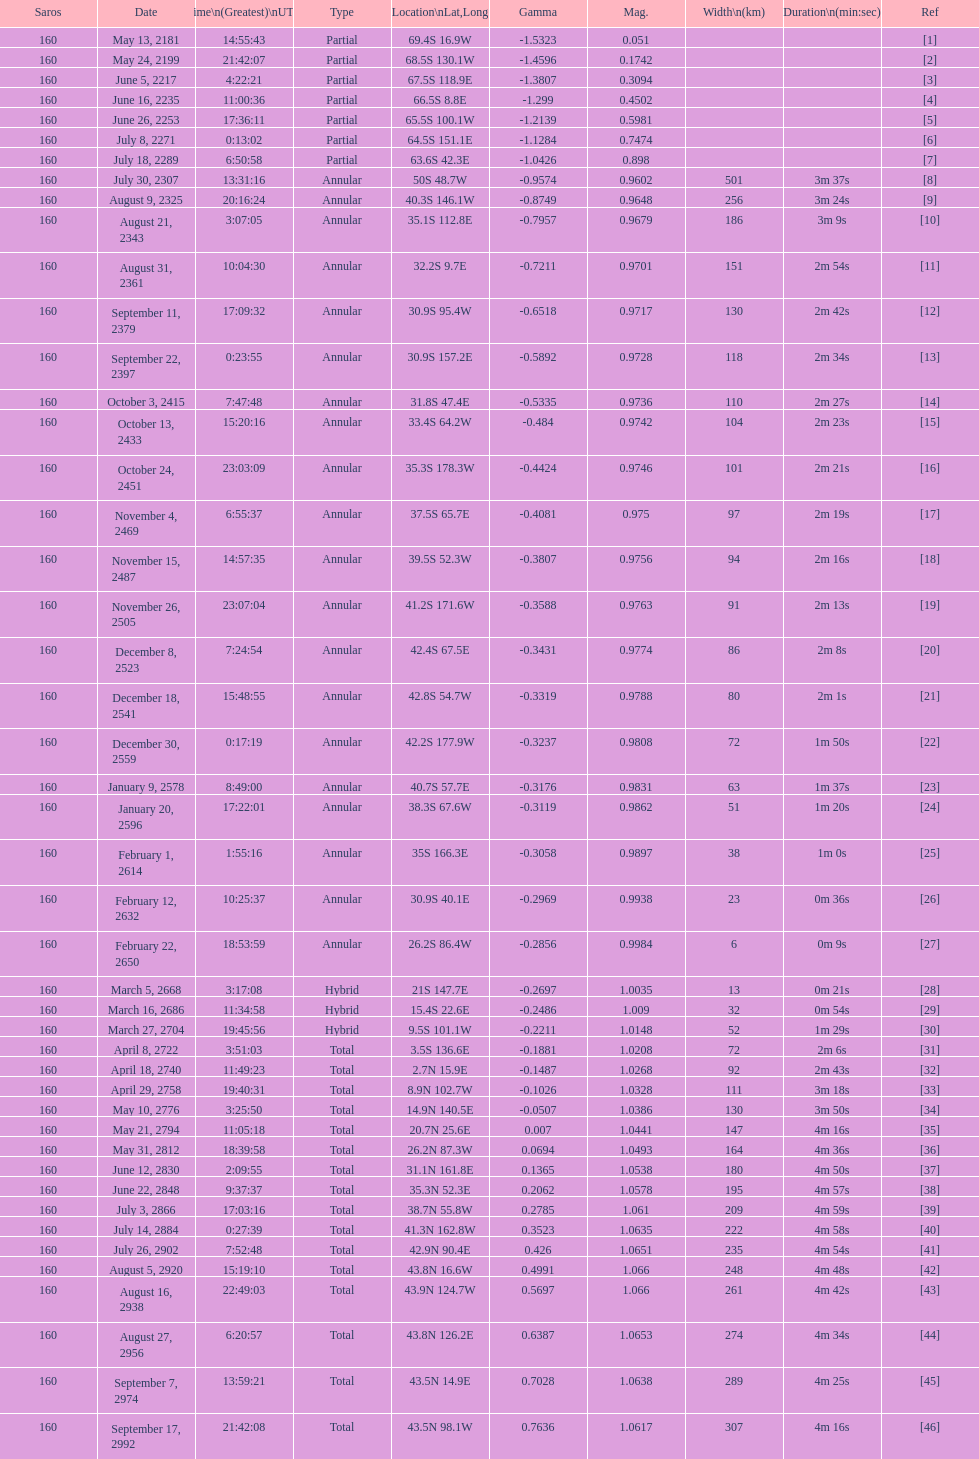Name one that has the same latitude as member number 12. 13. 